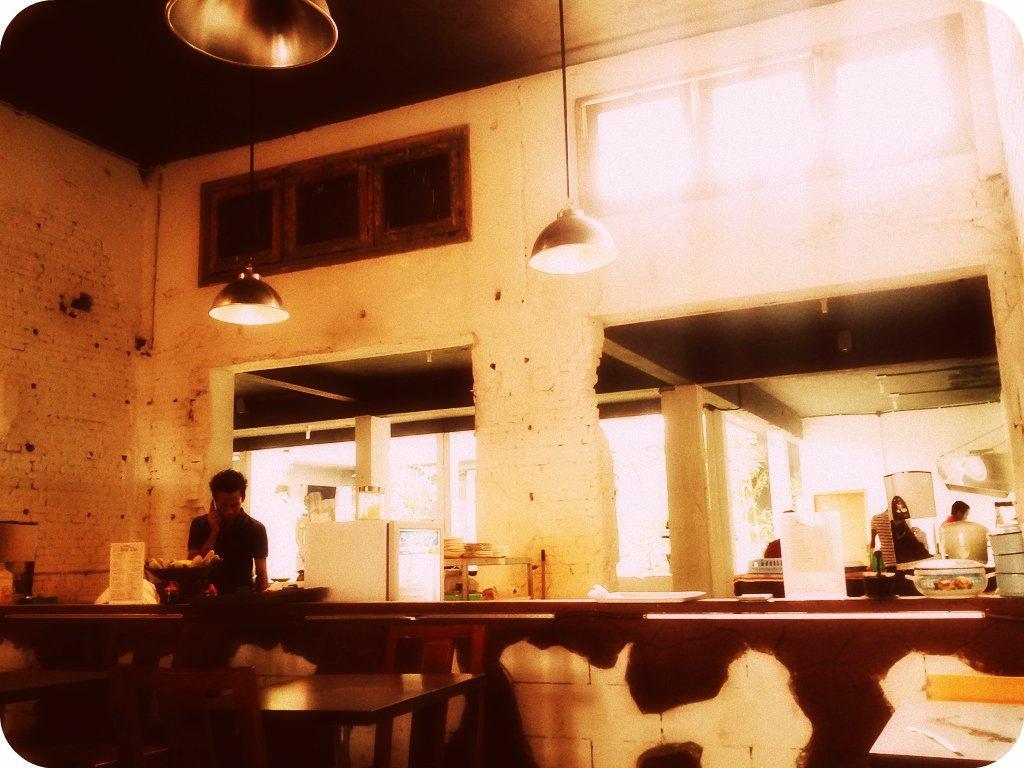Could you give a brief overview of what you see in this image? In this picture there is a man standing. There is a card, bowl ,tray on the table. There is also another man standing to the right. There are boxes, lights and a tree. 